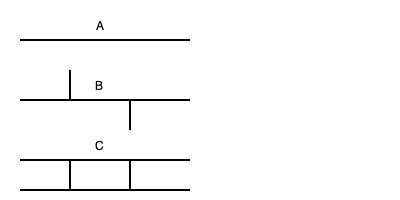Identify the polymer chain structures represented by diagrams A, B, and C. Which structure is most likely to exhibit the highest tensile strength? To identify the polymer chain structures and determine which has the highest tensile strength, let's analyze each diagram:

1. Diagram A: This represents a linear polymer chain. The structure is a straight line without any branches or cross-links.

2. Diagram B: This shows a branched polymer chain. The main chain has additional smaller chains branching off from it.

3. Diagram C: This illustrates a cross-linked polymer chain. Multiple polymer chains are connected by cross-links between them.

Now, let's consider the tensile strength of each structure:

1. Linear polymers (A) have moderate tensile strength. The chains can slide past each other under stress, allowing for some flexibility but limited strength.

2. Branched polymers (B) typically have lower tensile strength than linear polymers. The branches can interfere with chain packing, reducing intermolecular forces and allowing for easier deformation under stress.

3. Cross-linked polymers (C) generally have the highest tensile strength among these three structures. The cross-links between chains create a three-dimensional network that resists deformation and increases overall strength.

The cross-links in structure C prevent the polymer chains from sliding past each other easily, distributing stress more evenly throughout the material. This results in higher tensile strength compared to linear or branched polymers.

Therefore, the cross-linked polymer structure (C) is most likely to exhibit the highest tensile strength.
Answer: C (Cross-linked polymer) 